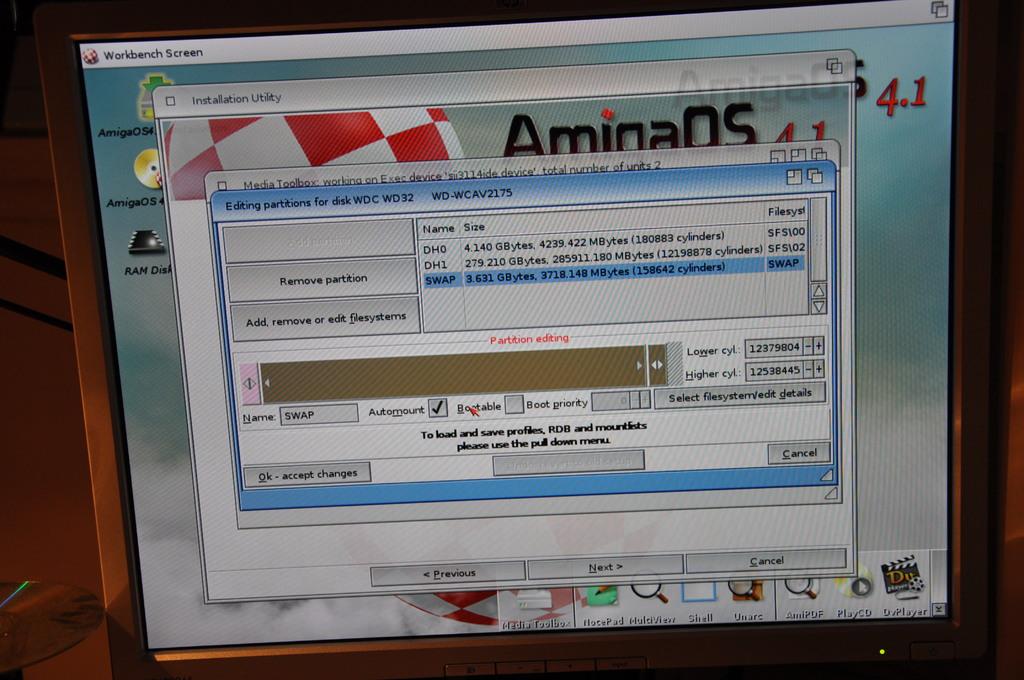What version is this software in?
Keep it short and to the point. 4.1. What is the title of the last screen?
Your answer should be very brief. Workbench screen. 